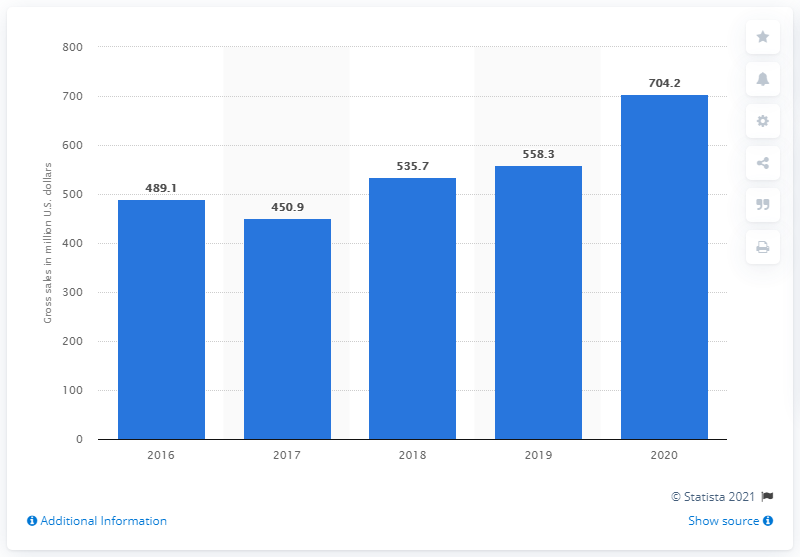Outline some significant characteristics in this image. In 2020, the gross sales of Mattel's Barbie brand were 704.2 million dollars. In the previous year, the gross sales of Mattel's Barbie brand were 558.3 million dollars. 